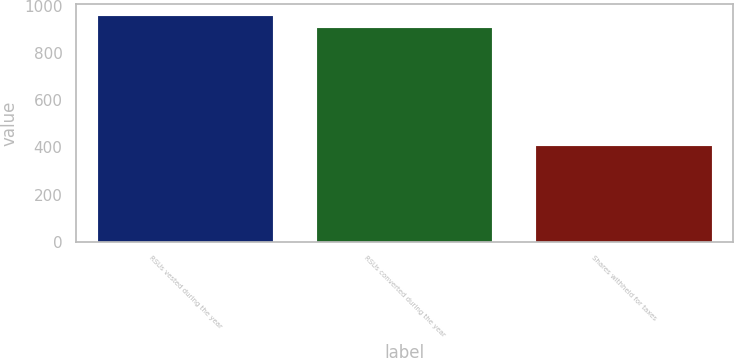Convert chart. <chart><loc_0><loc_0><loc_500><loc_500><bar_chart><fcel>RSUs vested during the year<fcel>RSUs converted during the year<fcel>Shares withheld for taxes<nl><fcel>958.5<fcel>905<fcel>407<nl></chart> 